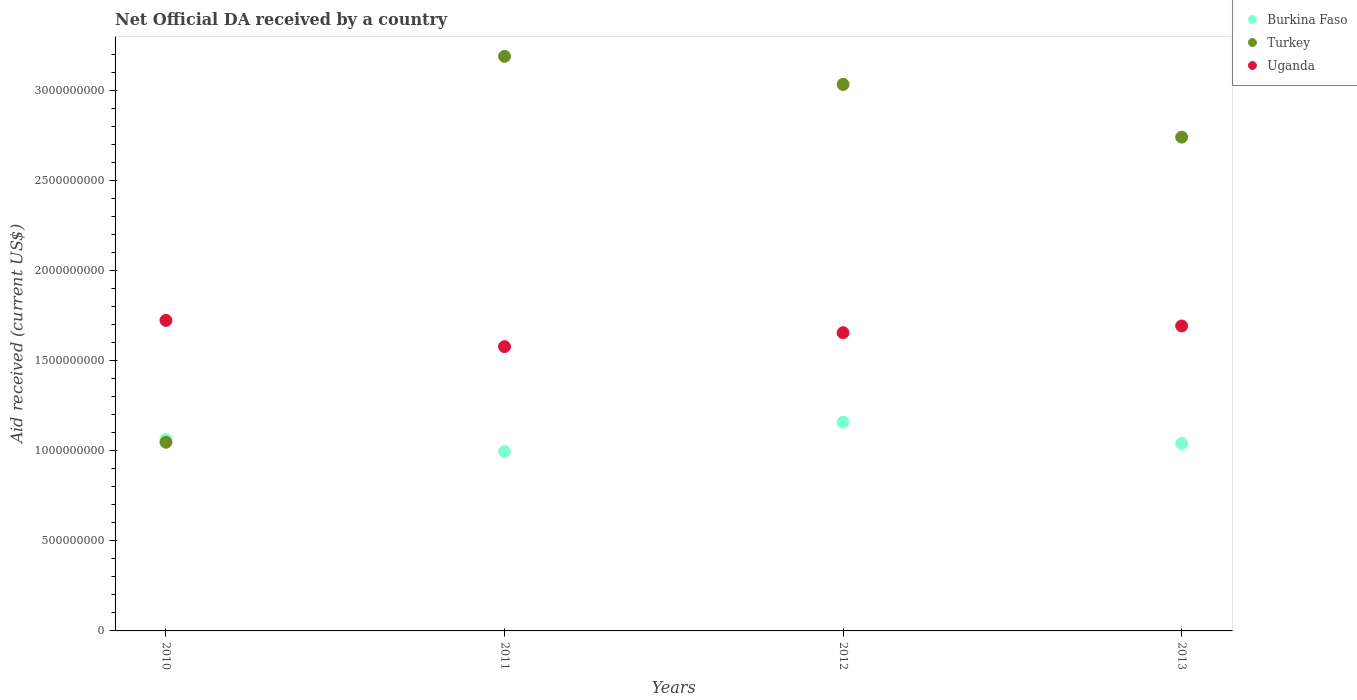Is the number of dotlines equal to the number of legend labels?
Provide a short and direct response. Yes. What is the net official development assistance aid received in Uganda in 2010?
Give a very brief answer. 1.72e+09. Across all years, what is the maximum net official development assistance aid received in Uganda?
Make the answer very short. 1.72e+09. Across all years, what is the minimum net official development assistance aid received in Uganda?
Your response must be concise. 1.58e+09. In which year was the net official development assistance aid received in Burkina Faso maximum?
Keep it short and to the point. 2012. What is the total net official development assistance aid received in Uganda in the graph?
Your response must be concise. 6.65e+09. What is the difference between the net official development assistance aid received in Burkina Faso in 2010 and that in 2011?
Give a very brief answer. 6.72e+07. What is the difference between the net official development assistance aid received in Turkey in 2013 and the net official development assistance aid received in Uganda in 2012?
Give a very brief answer. 1.09e+09. What is the average net official development assistance aid received in Burkina Faso per year?
Your answer should be compact. 1.06e+09. In the year 2010, what is the difference between the net official development assistance aid received in Uganda and net official development assistance aid received in Turkey?
Offer a terse response. 6.76e+08. What is the ratio of the net official development assistance aid received in Uganda in 2011 to that in 2012?
Your response must be concise. 0.95. Is the net official development assistance aid received in Uganda in 2010 less than that in 2011?
Offer a terse response. No. What is the difference between the highest and the second highest net official development assistance aid received in Uganda?
Provide a short and direct response. 3.09e+07. What is the difference between the highest and the lowest net official development assistance aid received in Uganda?
Provide a short and direct response. 1.46e+08. In how many years, is the net official development assistance aid received in Turkey greater than the average net official development assistance aid received in Turkey taken over all years?
Make the answer very short. 3. Does the net official development assistance aid received in Uganda monotonically increase over the years?
Keep it short and to the point. No. Is the net official development assistance aid received in Uganda strictly greater than the net official development assistance aid received in Burkina Faso over the years?
Provide a short and direct response. Yes. Does the graph contain any zero values?
Keep it short and to the point. No. Does the graph contain grids?
Offer a terse response. No. How many legend labels are there?
Your answer should be very brief. 3. What is the title of the graph?
Your response must be concise. Net Official DA received by a country. What is the label or title of the X-axis?
Your response must be concise. Years. What is the label or title of the Y-axis?
Make the answer very short. Aid received (current US$). What is the Aid received (current US$) of Burkina Faso in 2010?
Keep it short and to the point. 1.06e+09. What is the Aid received (current US$) in Turkey in 2010?
Offer a terse response. 1.05e+09. What is the Aid received (current US$) in Uganda in 2010?
Make the answer very short. 1.72e+09. What is the Aid received (current US$) in Burkina Faso in 2011?
Give a very brief answer. 9.95e+08. What is the Aid received (current US$) of Turkey in 2011?
Your answer should be compact. 3.19e+09. What is the Aid received (current US$) of Uganda in 2011?
Your response must be concise. 1.58e+09. What is the Aid received (current US$) of Burkina Faso in 2012?
Keep it short and to the point. 1.16e+09. What is the Aid received (current US$) of Turkey in 2012?
Provide a succinct answer. 3.03e+09. What is the Aid received (current US$) in Uganda in 2012?
Your answer should be very brief. 1.66e+09. What is the Aid received (current US$) of Burkina Faso in 2013?
Offer a terse response. 1.04e+09. What is the Aid received (current US$) of Turkey in 2013?
Make the answer very short. 2.74e+09. What is the Aid received (current US$) of Uganda in 2013?
Offer a very short reply. 1.69e+09. Across all years, what is the maximum Aid received (current US$) in Burkina Faso?
Provide a succinct answer. 1.16e+09. Across all years, what is the maximum Aid received (current US$) of Turkey?
Provide a short and direct response. 3.19e+09. Across all years, what is the maximum Aid received (current US$) in Uganda?
Give a very brief answer. 1.72e+09. Across all years, what is the minimum Aid received (current US$) of Burkina Faso?
Give a very brief answer. 9.95e+08. Across all years, what is the minimum Aid received (current US$) of Turkey?
Your response must be concise. 1.05e+09. Across all years, what is the minimum Aid received (current US$) in Uganda?
Provide a succinct answer. 1.58e+09. What is the total Aid received (current US$) of Burkina Faso in the graph?
Give a very brief answer. 4.26e+09. What is the total Aid received (current US$) of Turkey in the graph?
Your answer should be very brief. 1.00e+1. What is the total Aid received (current US$) of Uganda in the graph?
Provide a succinct answer. 6.65e+09. What is the difference between the Aid received (current US$) of Burkina Faso in 2010 and that in 2011?
Make the answer very short. 6.72e+07. What is the difference between the Aid received (current US$) of Turkey in 2010 and that in 2011?
Give a very brief answer. -2.14e+09. What is the difference between the Aid received (current US$) of Uganda in 2010 and that in 2011?
Your response must be concise. 1.46e+08. What is the difference between the Aid received (current US$) of Burkina Faso in 2010 and that in 2012?
Give a very brief answer. -9.62e+07. What is the difference between the Aid received (current US$) in Turkey in 2010 and that in 2012?
Ensure brevity in your answer.  -1.99e+09. What is the difference between the Aid received (current US$) of Uganda in 2010 and that in 2012?
Make the answer very short. 6.83e+07. What is the difference between the Aid received (current US$) in Burkina Faso in 2010 and that in 2013?
Your answer should be compact. 2.22e+07. What is the difference between the Aid received (current US$) of Turkey in 2010 and that in 2013?
Your response must be concise. -1.69e+09. What is the difference between the Aid received (current US$) in Uganda in 2010 and that in 2013?
Your response must be concise. 3.09e+07. What is the difference between the Aid received (current US$) in Burkina Faso in 2011 and that in 2012?
Offer a very short reply. -1.63e+08. What is the difference between the Aid received (current US$) in Turkey in 2011 and that in 2012?
Keep it short and to the point. 1.56e+08. What is the difference between the Aid received (current US$) of Uganda in 2011 and that in 2012?
Offer a terse response. -7.74e+07. What is the difference between the Aid received (current US$) in Burkina Faso in 2011 and that in 2013?
Your response must be concise. -4.50e+07. What is the difference between the Aid received (current US$) of Turkey in 2011 and that in 2013?
Keep it short and to the point. 4.48e+08. What is the difference between the Aid received (current US$) in Uganda in 2011 and that in 2013?
Offer a very short reply. -1.15e+08. What is the difference between the Aid received (current US$) in Burkina Faso in 2012 and that in 2013?
Offer a terse response. 1.18e+08. What is the difference between the Aid received (current US$) of Turkey in 2012 and that in 2013?
Your response must be concise. 2.93e+08. What is the difference between the Aid received (current US$) of Uganda in 2012 and that in 2013?
Your answer should be very brief. -3.74e+07. What is the difference between the Aid received (current US$) in Burkina Faso in 2010 and the Aid received (current US$) in Turkey in 2011?
Provide a short and direct response. -2.13e+09. What is the difference between the Aid received (current US$) of Burkina Faso in 2010 and the Aid received (current US$) of Uganda in 2011?
Provide a short and direct response. -5.15e+08. What is the difference between the Aid received (current US$) of Turkey in 2010 and the Aid received (current US$) of Uganda in 2011?
Make the answer very short. -5.31e+08. What is the difference between the Aid received (current US$) in Burkina Faso in 2010 and the Aid received (current US$) in Turkey in 2012?
Give a very brief answer. -1.97e+09. What is the difference between the Aid received (current US$) of Burkina Faso in 2010 and the Aid received (current US$) of Uganda in 2012?
Provide a short and direct response. -5.93e+08. What is the difference between the Aid received (current US$) of Turkey in 2010 and the Aid received (current US$) of Uganda in 2012?
Ensure brevity in your answer.  -6.08e+08. What is the difference between the Aid received (current US$) in Burkina Faso in 2010 and the Aid received (current US$) in Turkey in 2013?
Provide a short and direct response. -1.68e+09. What is the difference between the Aid received (current US$) in Burkina Faso in 2010 and the Aid received (current US$) in Uganda in 2013?
Your answer should be compact. -6.30e+08. What is the difference between the Aid received (current US$) of Turkey in 2010 and the Aid received (current US$) of Uganda in 2013?
Offer a very short reply. -6.45e+08. What is the difference between the Aid received (current US$) in Burkina Faso in 2011 and the Aid received (current US$) in Turkey in 2012?
Provide a succinct answer. -2.04e+09. What is the difference between the Aid received (current US$) in Burkina Faso in 2011 and the Aid received (current US$) in Uganda in 2012?
Offer a terse response. -6.60e+08. What is the difference between the Aid received (current US$) in Turkey in 2011 and the Aid received (current US$) in Uganda in 2012?
Your response must be concise. 1.53e+09. What is the difference between the Aid received (current US$) of Burkina Faso in 2011 and the Aid received (current US$) of Turkey in 2013?
Provide a succinct answer. -1.75e+09. What is the difference between the Aid received (current US$) of Burkina Faso in 2011 and the Aid received (current US$) of Uganda in 2013?
Keep it short and to the point. -6.97e+08. What is the difference between the Aid received (current US$) in Turkey in 2011 and the Aid received (current US$) in Uganda in 2013?
Your answer should be compact. 1.50e+09. What is the difference between the Aid received (current US$) in Burkina Faso in 2012 and the Aid received (current US$) in Turkey in 2013?
Your answer should be compact. -1.58e+09. What is the difference between the Aid received (current US$) of Burkina Faso in 2012 and the Aid received (current US$) of Uganda in 2013?
Your answer should be compact. -5.34e+08. What is the difference between the Aid received (current US$) in Turkey in 2012 and the Aid received (current US$) in Uganda in 2013?
Your answer should be very brief. 1.34e+09. What is the average Aid received (current US$) in Burkina Faso per year?
Give a very brief answer. 1.06e+09. What is the average Aid received (current US$) of Turkey per year?
Offer a very short reply. 2.50e+09. What is the average Aid received (current US$) in Uganda per year?
Offer a very short reply. 1.66e+09. In the year 2010, what is the difference between the Aid received (current US$) of Burkina Faso and Aid received (current US$) of Turkey?
Ensure brevity in your answer.  1.52e+07. In the year 2010, what is the difference between the Aid received (current US$) of Burkina Faso and Aid received (current US$) of Uganda?
Provide a short and direct response. -6.61e+08. In the year 2010, what is the difference between the Aid received (current US$) of Turkey and Aid received (current US$) of Uganda?
Give a very brief answer. -6.76e+08. In the year 2011, what is the difference between the Aid received (current US$) of Burkina Faso and Aid received (current US$) of Turkey?
Your response must be concise. -2.19e+09. In the year 2011, what is the difference between the Aid received (current US$) in Burkina Faso and Aid received (current US$) in Uganda?
Offer a terse response. -5.83e+08. In the year 2011, what is the difference between the Aid received (current US$) of Turkey and Aid received (current US$) of Uganda?
Make the answer very short. 1.61e+09. In the year 2012, what is the difference between the Aid received (current US$) in Burkina Faso and Aid received (current US$) in Turkey?
Keep it short and to the point. -1.87e+09. In the year 2012, what is the difference between the Aid received (current US$) of Burkina Faso and Aid received (current US$) of Uganda?
Offer a very short reply. -4.97e+08. In the year 2012, what is the difference between the Aid received (current US$) in Turkey and Aid received (current US$) in Uganda?
Provide a succinct answer. 1.38e+09. In the year 2013, what is the difference between the Aid received (current US$) in Burkina Faso and Aid received (current US$) in Turkey?
Make the answer very short. -1.70e+09. In the year 2013, what is the difference between the Aid received (current US$) of Burkina Faso and Aid received (current US$) of Uganda?
Your answer should be very brief. -6.52e+08. In the year 2013, what is the difference between the Aid received (current US$) in Turkey and Aid received (current US$) in Uganda?
Your answer should be very brief. 1.05e+09. What is the ratio of the Aid received (current US$) of Burkina Faso in 2010 to that in 2011?
Your response must be concise. 1.07. What is the ratio of the Aid received (current US$) in Turkey in 2010 to that in 2011?
Offer a terse response. 0.33. What is the ratio of the Aid received (current US$) of Uganda in 2010 to that in 2011?
Offer a terse response. 1.09. What is the ratio of the Aid received (current US$) in Burkina Faso in 2010 to that in 2012?
Offer a very short reply. 0.92. What is the ratio of the Aid received (current US$) in Turkey in 2010 to that in 2012?
Give a very brief answer. 0.35. What is the ratio of the Aid received (current US$) in Uganda in 2010 to that in 2012?
Provide a short and direct response. 1.04. What is the ratio of the Aid received (current US$) in Burkina Faso in 2010 to that in 2013?
Offer a very short reply. 1.02. What is the ratio of the Aid received (current US$) in Turkey in 2010 to that in 2013?
Provide a succinct answer. 0.38. What is the ratio of the Aid received (current US$) in Uganda in 2010 to that in 2013?
Offer a terse response. 1.02. What is the ratio of the Aid received (current US$) in Burkina Faso in 2011 to that in 2012?
Keep it short and to the point. 0.86. What is the ratio of the Aid received (current US$) in Turkey in 2011 to that in 2012?
Ensure brevity in your answer.  1.05. What is the ratio of the Aid received (current US$) of Uganda in 2011 to that in 2012?
Ensure brevity in your answer.  0.95. What is the ratio of the Aid received (current US$) of Burkina Faso in 2011 to that in 2013?
Provide a succinct answer. 0.96. What is the ratio of the Aid received (current US$) of Turkey in 2011 to that in 2013?
Offer a terse response. 1.16. What is the ratio of the Aid received (current US$) of Uganda in 2011 to that in 2013?
Provide a succinct answer. 0.93. What is the ratio of the Aid received (current US$) in Burkina Faso in 2012 to that in 2013?
Your response must be concise. 1.11. What is the ratio of the Aid received (current US$) in Turkey in 2012 to that in 2013?
Give a very brief answer. 1.11. What is the ratio of the Aid received (current US$) in Uganda in 2012 to that in 2013?
Your answer should be very brief. 0.98. What is the difference between the highest and the second highest Aid received (current US$) of Burkina Faso?
Your response must be concise. 9.62e+07. What is the difference between the highest and the second highest Aid received (current US$) of Turkey?
Provide a short and direct response. 1.56e+08. What is the difference between the highest and the second highest Aid received (current US$) of Uganda?
Your answer should be compact. 3.09e+07. What is the difference between the highest and the lowest Aid received (current US$) in Burkina Faso?
Your answer should be compact. 1.63e+08. What is the difference between the highest and the lowest Aid received (current US$) in Turkey?
Ensure brevity in your answer.  2.14e+09. What is the difference between the highest and the lowest Aid received (current US$) of Uganda?
Your response must be concise. 1.46e+08. 